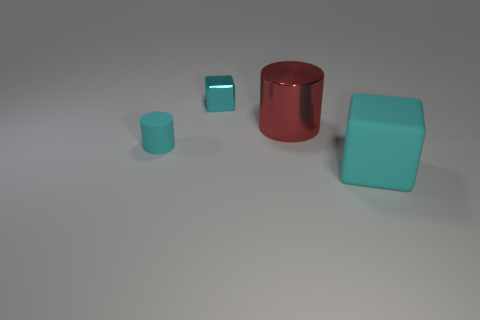Are there the same number of small cyan metallic objects behind the cyan metal thing and big blue spheres?
Make the answer very short. Yes. What number of objects are to the left of the red metallic cylinder and on the right side of the cyan cylinder?
Your answer should be very brief. 1. There is a red metallic object that is the same shape as the tiny cyan matte object; what is its size?
Provide a short and direct response. Large. What number of cyan things are the same material as the small cylinder?
Your answer should be very brief. 1. Is the number of cyan rubber things behind the small cyan rubber cylinder less than the number of brown rubber balls?
Provide a succinct answer. No. How many big red metal objects are there?
Your answer should be compact. 1. What number of metal objects are the same color as the large cube?
Keep it short and to the point. 1. Do the red shiny thing and the small cyan rubber object have the same shape?
Provide a short and direct response. Yes. What size is the red shiny thing left of the large thing that is on the right side of the big red cylinder?
Ensure brevity in your answer.  Large. Are there any cyan things of the same size as the red cylinder?
Give a very brief answer. Yes. 